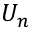<formula> <loc_0><loc_0><loc_500><loc_500>U _ { n }</formula> 